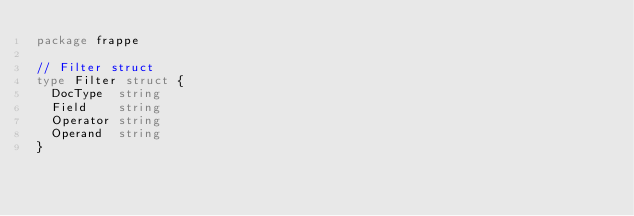<code> <loc_0><loc_0><loc_500><loc_500><_Go_>package frappe

// Filter struct
type Filter struct {
	DocType  string
	Field    string
	Operator string
	Operand  string
}
</code> 